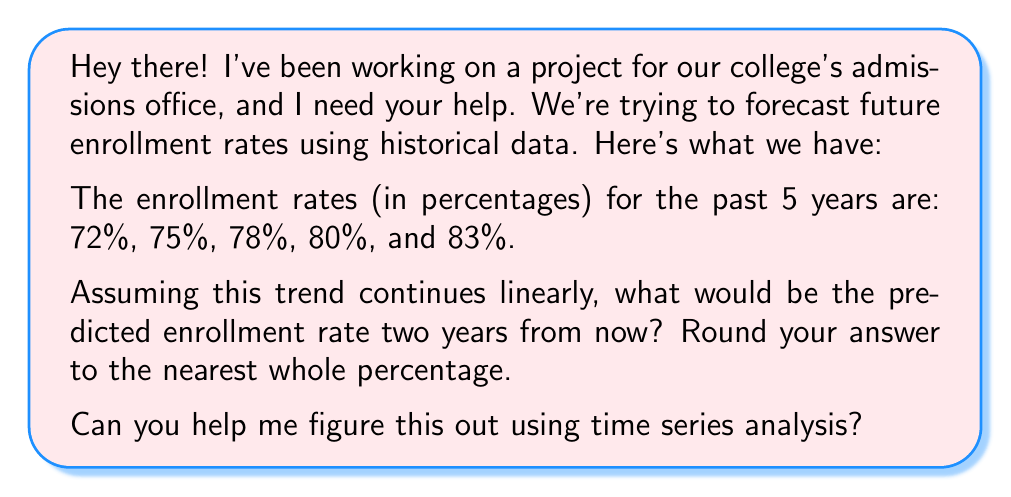Can you answer this question? Sure thing! Let's break this down step-by-step using a simple linear trend model:

1) First, let's assign time values to our data points:
   Year 1: 72%
   Year 2: 75%
   Year 3: 78%
   Year 4: 80%
   Year 5: 83%

2) To find the linear trend, we need to calculate the average increase per year:

   $\text{Average increase} = \frac{\text{Total increase}}{\text{Number of intervals}}$

   $= \frac{83\% - 72\%}{5-1} = \frac{11\%}{4} = 2.75\%$ per year

3) Now that we have the trend, we can forecast future values using the formula:

   $\text{Forecast} = \text{Last observed value} + \text{Trend} \times \text{Number of periods ahead}$

4) We want to forecast 2 years ahead, so:

   $\text{Forecast} = 83\% + 2.75\% \times 2 = 83\% + 5.5\% = 88.5\%$

5) Rounding to the nearest whole percentage:

   $88.5\% \approx 89\%$

This method assumes that the trend we've observed in the past 5 years will continue linearly into the future, which may not always be the case in real-world scenarios. More complex time series models could provide more accurate forecasts if the trend is non-linear or if there are seasonal patterns.
Answer: 89% 